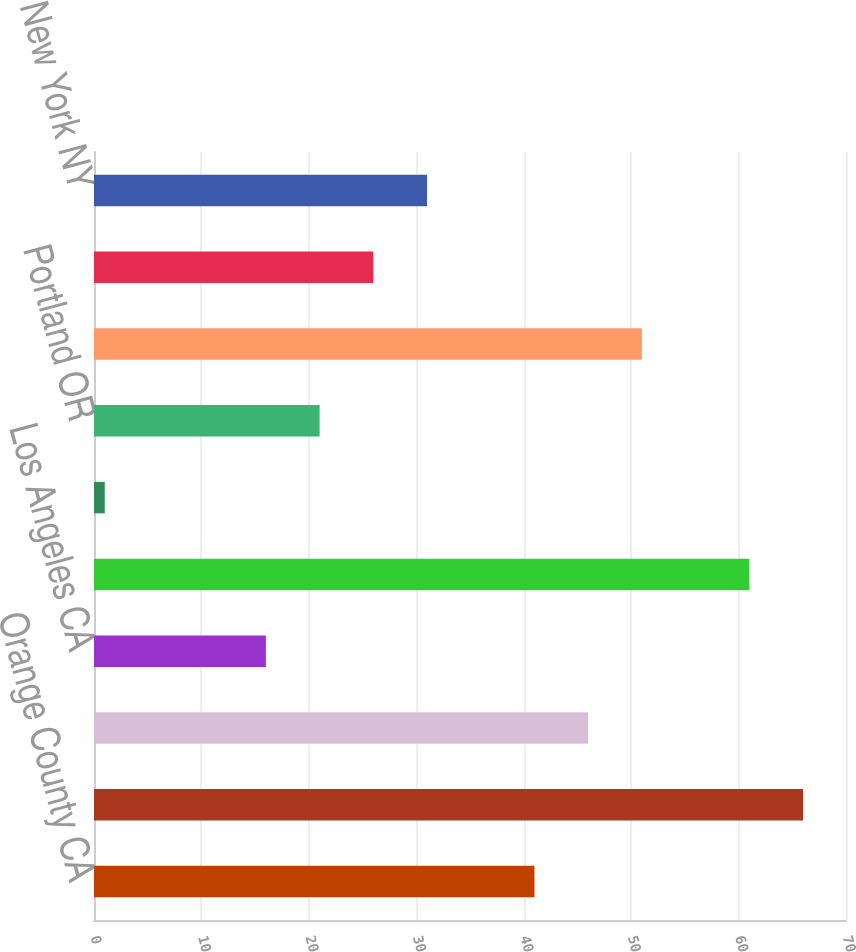Convert chart to OTSL. <chart><loc_0><loc_0><loc_500><loc_500><bar_chart><fcel>Orange County CA<fcel>San Francisco CA<fcel>Seattle WA<fcel>Los Angeles CA<fcel>Monterey Peninsula CA<fcel>Other Southern California<fcel>Portland OR<fcel>Metropolitan DC<fcel>Baltimore MD<fcel>New York NY<nl><fcel>41<fcel>66<fcel>46<fcel>16<fcel>61<fcel>1<fcel>21<fcel>51<fcel>26<fcel>31<nl></chart> 